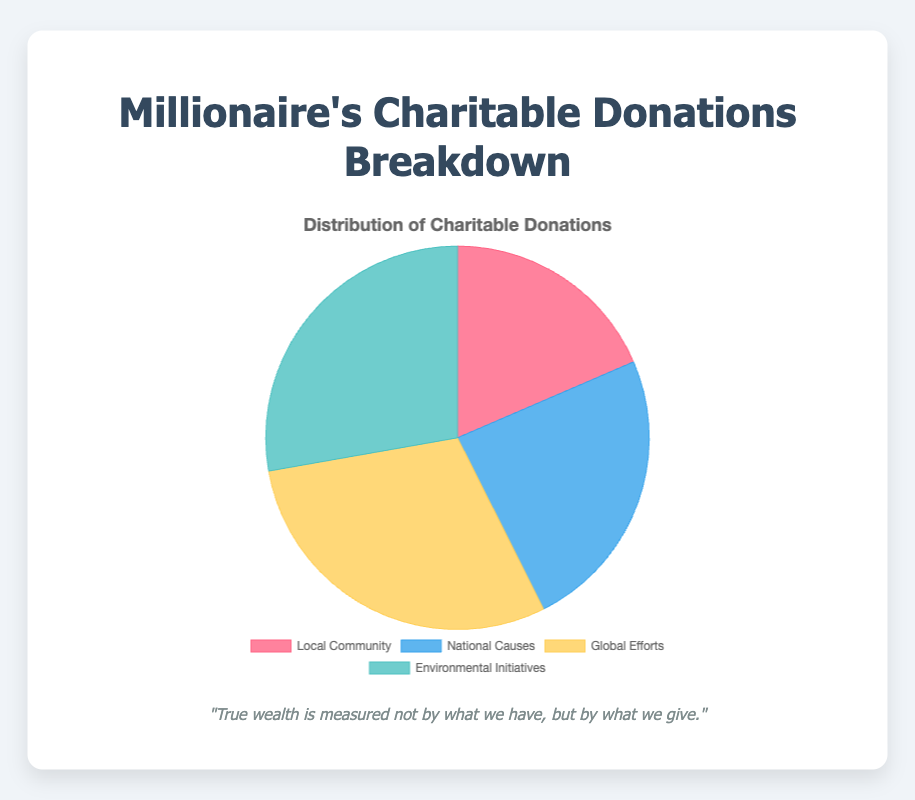What percentage of the total donations is allocated to Local Community causes? First, calculate the total amount allocated to charitable donations: $1,000,000 (Local Community) + $1,300,000 (National Causes) + $1,600,000 (Global Efforts) + $1,500,000 (Environmental Initiatives) = $5,400,000. Then, find the percentage of Local Community donations: ($1,000,000 / $5,400,000) * 100 = 18.52%.
Answer: 18.52% Which category received the highest amount of donations? By looking at the data, compare the amounts: Local Community ($1,000,000), National Causes ($1,300,000), Global Efforts ($1,600,000), and Environmental Initiatives ($1,500,000). The highest amount is $1,600,000 for Global Efforts.
Answer: Global Efforts How much more is donated to Environmental Initiatives compared to Local Community causes? Subtract the amount donated to Local Community ($1,000,000) from the amount donated to Environmental Initiatives ($1,500,000): $1,500,000 - $1,000,000 = $500,000.
Answer: $500,000 What is the combined donation amount for National Causes and Environmental Initiatives? Add the amounts for National Causes ($1,300,000) and Environmental Initiatives ($1,500,000): $1,300,000 + $1,500,000 = $2,800,000.
Answer: $2,800,000 If you were to rank the donation categories from highest to lowest, what would the order be? The donation amounts are: Global Efforts ($1,600,000), Environmental Initiatives ($1,500,000), National Causes ($1,300,000), and Local Community ($1,000,000). Therefore, the order is: 1. Global Efforts 2. Environmental Initiatives 3. National Causes 4. Local Community.
Answer: Global Efforts, Environmental Initiatives, National Causes, Local Community What color is used to represent National Causes in the pie chart? The color for National Causes in the pie chart is blue.
Answer: Blue How does the total donation for Global Efforts compare to the total for National Causes and Environmental Initiatives combined? First, calculate the combined total of National Causes and Environmental Initiatives: $1,300,000 (National Causes) + $1,500,000 (Environmental Initiatives) = $2,800,000. Then, compare it to the total for Global Efforts ($1,600,000). $2,800,000 (combined) > $1,600,000 (Global Efforts).
Answer: Less Which category has the least donations, and how much less is it than the highest category? Local Community has the least donations at $1,000,000. The highest category is Global Efforts at $1,600,000. Subtract the least from the highest: $1,600,000 - $1,000,000 = $600,000.
Answer: Local Community, $600,000 What is the total amount donated to causes labeled under 'Environmental Initiatives'? Summing up the amounts for Environmental Initiatives: Reforestation Projects ($600,000), Renewable Energy Research ($500,000), Conservation Programs ($400,000) gives a total of $1,500,000.
Answer: $1,500,000 How much does the Global Efforts category contribute compared to the total amount of donations? The amount for Global Efforts is $1,600,000. The total donations amount to $5,400,000. Therefore, its contribution percentage is ($1,600,000 / $5,400,000) * 100 = 29.63%.
Answer: 29.63% 